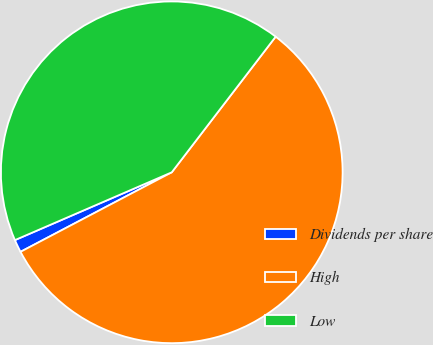Convert chart to OTSL. <chart><loc_0><loc_0><loc_500><loc_500><pie_chart><fcel>Dividends per share<fcel>High<fcel>Low<nl><fcel>1.21%<fcel>56.89%<fcel>41.9%<nl></chart> 